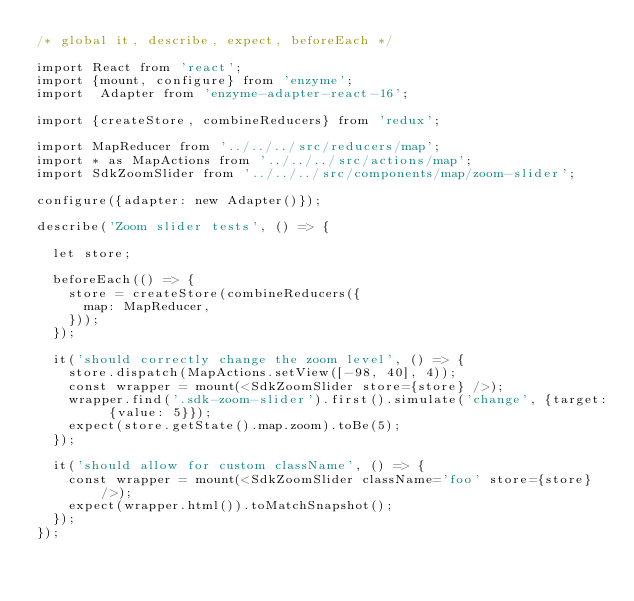Convert code to text. <code><loc_0><loc_0><loc_500><loc_500><_JavaScript_>/* global it, describe, expect, beforeEach */

import React from 'react';
import {mount, configure} from 'enzyme';
import  Adapter from 'enzyme-adapter-react-16';

import {createStore, combineReducers} from 'redux';

import MapReducer from '../../../src/reducers/map';
import * as MapActions from '../../../src/actions/map';
import SdkZoomSlider from '../../../src/components/map/zoom-slider';

configure({adapter: new Adapter()});

describe('Zoom slider tests', () => {

  let store;

  beforeEach(() => {
    store = createStore(combineReducers({
      map: MapReducer,
    }));
  });

  it('should correctly change the zoom level', () => {
    store.dispatch(MapActions.setView([-98, 40], 4));
    const wrapper = mount(<SdkZoomSlider store={store} />);
    wrapper.find('.sdk-zoom-slider').first().simulate('change', {target: {value: 5}});
    expect(store.getState().map.zoom).toBe(5);
  });

  it('should allow for custom className', () => {
    const wrapper = mount(<SdkZoomSlider className='foo' store={store} />);
    expect(wrapper.html()).toMatchSnapshot();
  });
});
</code> 